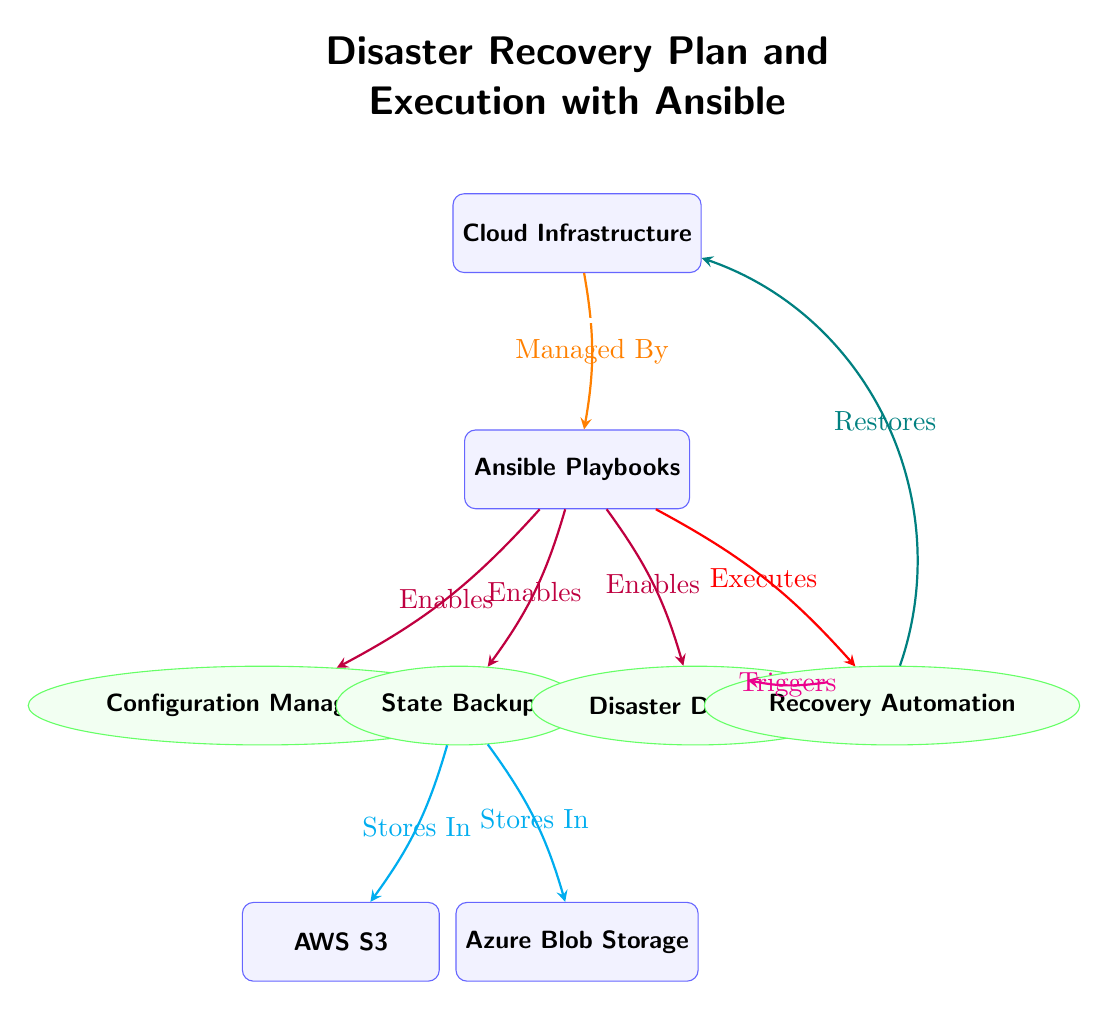What is the central entity in the diagram? The diagram centers around the "Cloud Infrastructure" node, which is depicted at the top of the diagram.
Answer: Cloud Infrastructure How many entities are present in the diagram? There are five entities depicted, namely "Cloud Infrastructure," "Ansible Playbooks," "AWS S3," "Azure Blob Storage." The "Ansible Playbooks" acts as a central function but isn't counted as an entity.
Answer: 5 What action does Ansible Playbooks execute that is related to disaster recovery? The diagram shows that "Ansible Playbooks" executes "Recovery Automation," which is critical for the disaster recovery process.
Answer: Recovery Automation Which entity is responsible for storing backups? The "State Backup" function, shown in the diagram, is responsible for the action of storing backups, which connects to both AWS S3 and Azure Blob Storage.
Answer: State Backup What triggers the "Recovery Automation"? "Disaster Detection" function triggers the "Recovery Automation" according to the diagram, indicating a flow from detecting issues to automating recovery processes.
Answer: Disaster Detection How does "State Backup" interact with external storage services? The "State Backup" function has edges directed towards both "AWS S3" and "Azure Blob Storage," indicating that it stores backup information in these external storage solutions.
Answer: Stores In What role does "Cloud Infrastructure" play in the diagram? The "Cloud Infrastructure" acts as the main governing node, indicated by the "Managed By" relationship with "Ansible Playbooks," which implies it is managed through Ansible for disaster recovery purposes.
Answer: Managed By Identify the function that directly implies the need for recovery. "Disaster Detection" indicates the necessity for recovery by triggering further steps in the disaster recovery plan, as laid out in the diagram.
Answer: Disaster Detection What is the relationship between "Recovery Automation" and "Cloud Infrastructure"? "Recovery Automation" restores the state of the "Cloud Infrastructure" after a disaster, indicating a direct link aiming to revert the infrastructure to its previous state post-disaster.
Answer: Restores 